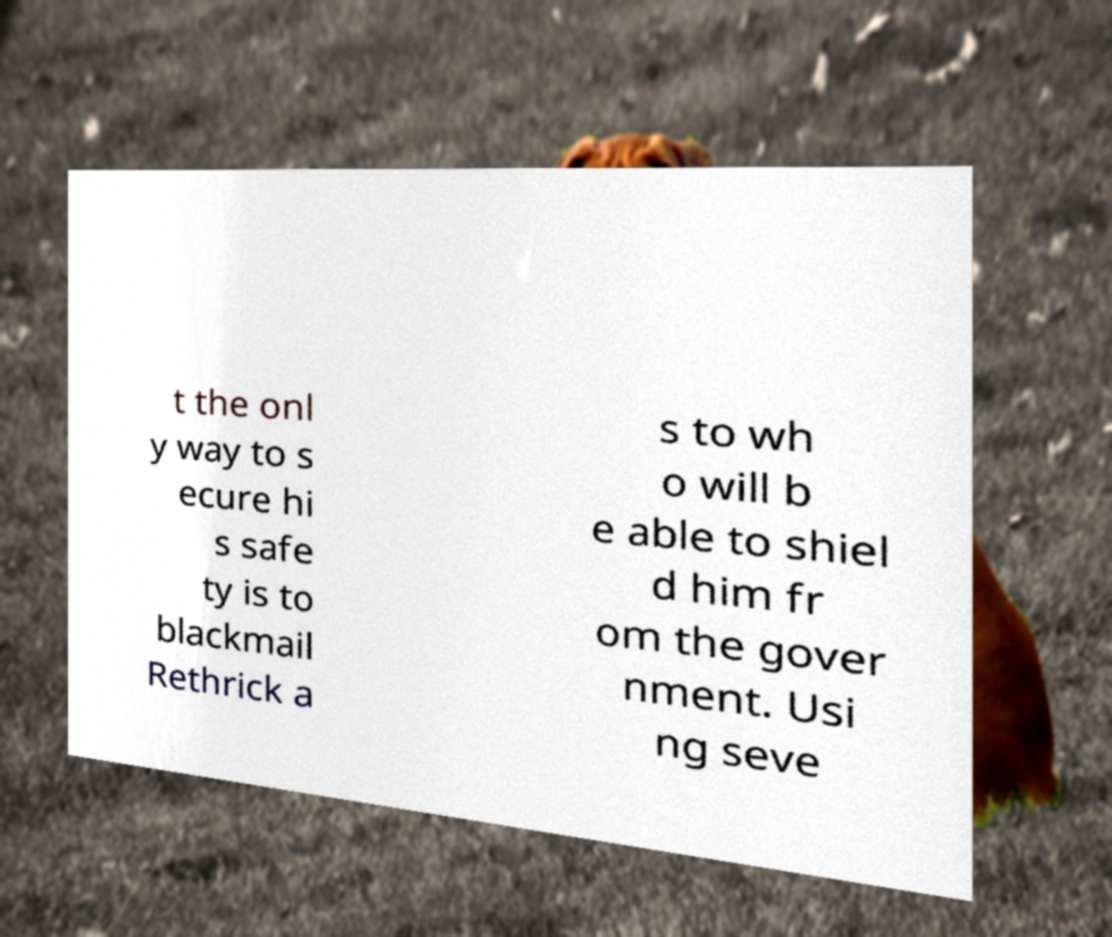Please read and relay the text visible in this image. What does it say? t the onl y way to s ecure hi s safe ty is to blackmail Rethrick a s to wh o will b e able to shiel d him fr om the gover nment. Usi ng seve 